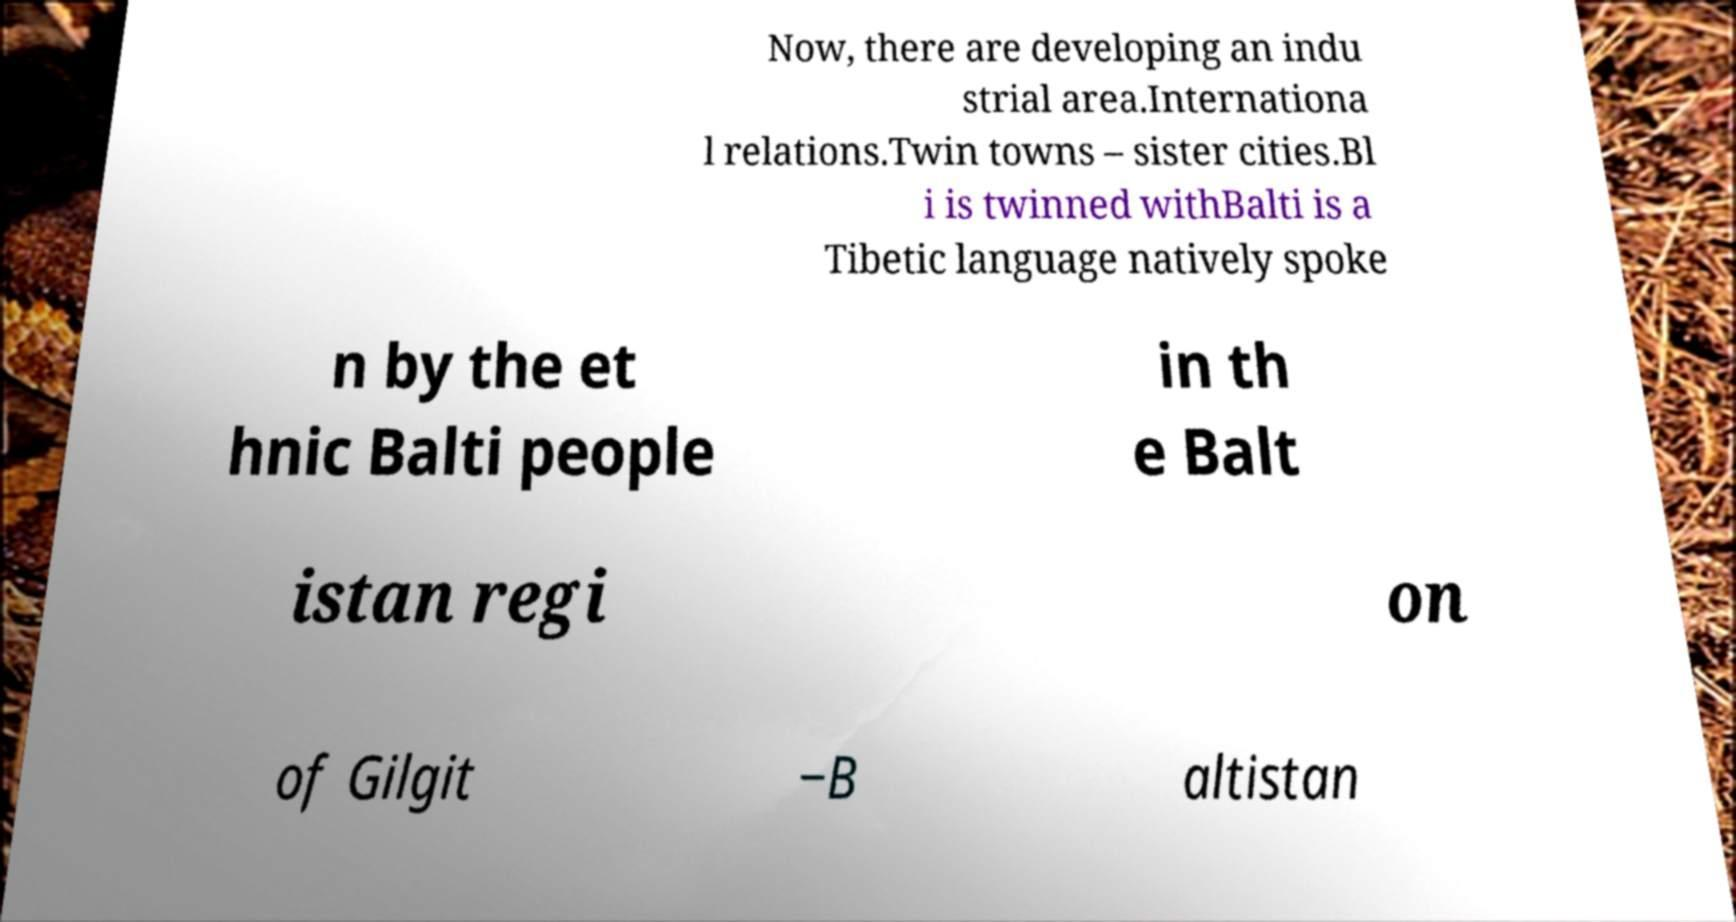Can you accurately transcribe the text from the provided image for me? Now, there are developing an indu strial area.Internationa l relations.Twin towns – sister cities.Bl i is twinned withBalti is a Tibetic language natively spoke n by the et hnic Balti people in th e Balt istan regi on of Gilgit −B altistan 